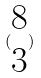Convert formula to latex. <formula><loc_0><loc_0><loc_500><loc_500>( \begin{matrix} 8 \\ 3 \end{matrix} )</formula> 